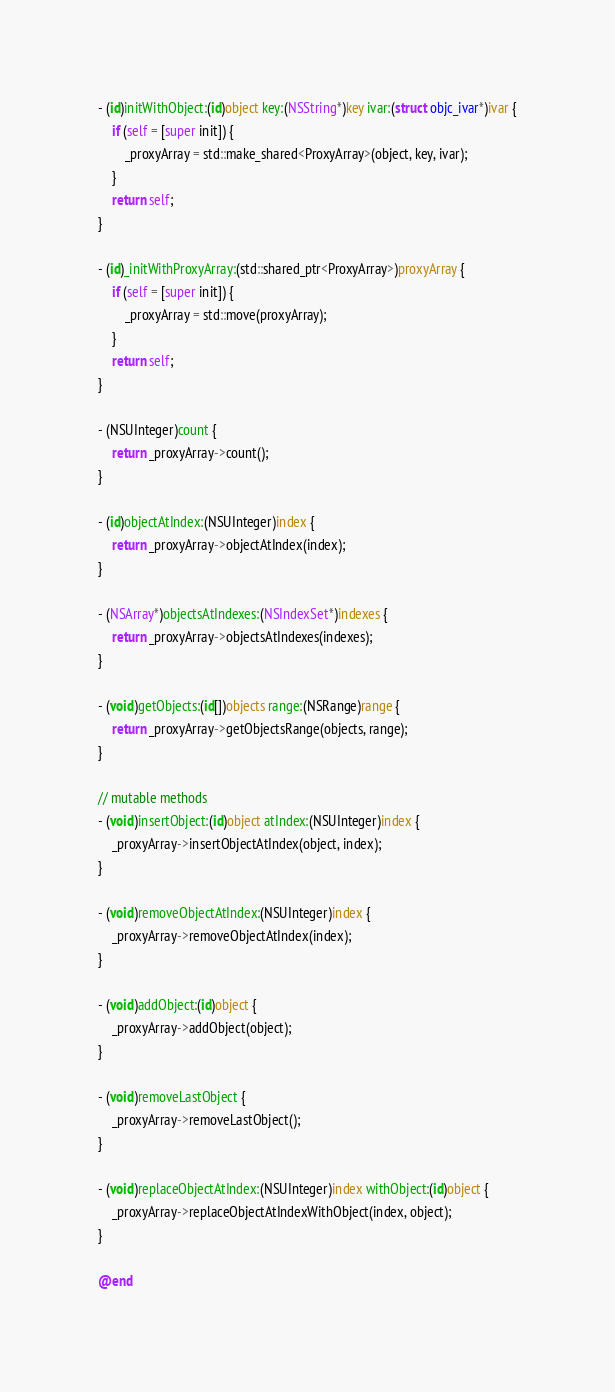<code> <loc_0><loc_0><loc_500><loc_500><_ObjectiveC_>- (id)initWithObject:(id)object key:(NSString*)key ivar:(struct objc_ivar*)ivar {
    if (self = [super init]) {
        _proxyArray = std::make_shared<ProxyArray>(object, key, ivar);
    }
    return self;
}

- (id)_initWithProxyArray:(std::shared_ptr<ProxyArray>)proxyArray {
    if (self = [super init]) {
        _proxyArray = std::move(proxyArray);
    }
    return self;
}

- (NSUInteger)count {
    return _proxyArray->count();
}

- (id)objectAtIndex:(NSUInteger)index {
    return _proxyArray->objectAtIndex(index);
}

- (NSArray*)objectsAtIndexes:(NSIndexSet*)indexes {
    return _proxyArray->objectsAtIndexes(indexes);
}

- (void)getObjects:(id[])objects range:(NSRange)range {
    return _proxyArray->getObjectsRange(objects, range);
}

// mutable methods
- (void)insertObject:(id)object atIndex:(NSUInteger)index {
    _proxyArray->insertObjectAtIndex(object, index);
}

- (void)removeObjectAtIndex:(NSUInteger)index {
    _proxyArray->removeObjectAtIndex(index);
}

- (void)addObject:(id)object {
    _proxyArray->addObject(object);
}

- (void)removeLastObject {
    _proxyArray->removeLastObject();
}

- (void)replaceObjectAtIndex:(NSUInteger)index withObject:(id)object {
    _proxyArray->replaceObjectAtIndexWithObject(index, object);
}

@end
</code> 